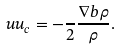Convert formula to latex. <formula><loc_0><loc_0><loc_500><loc_500>\ u u _ { c } = - \frac { } { 2 } \frac { \nabla b \rho } { \rho } .</formula> 